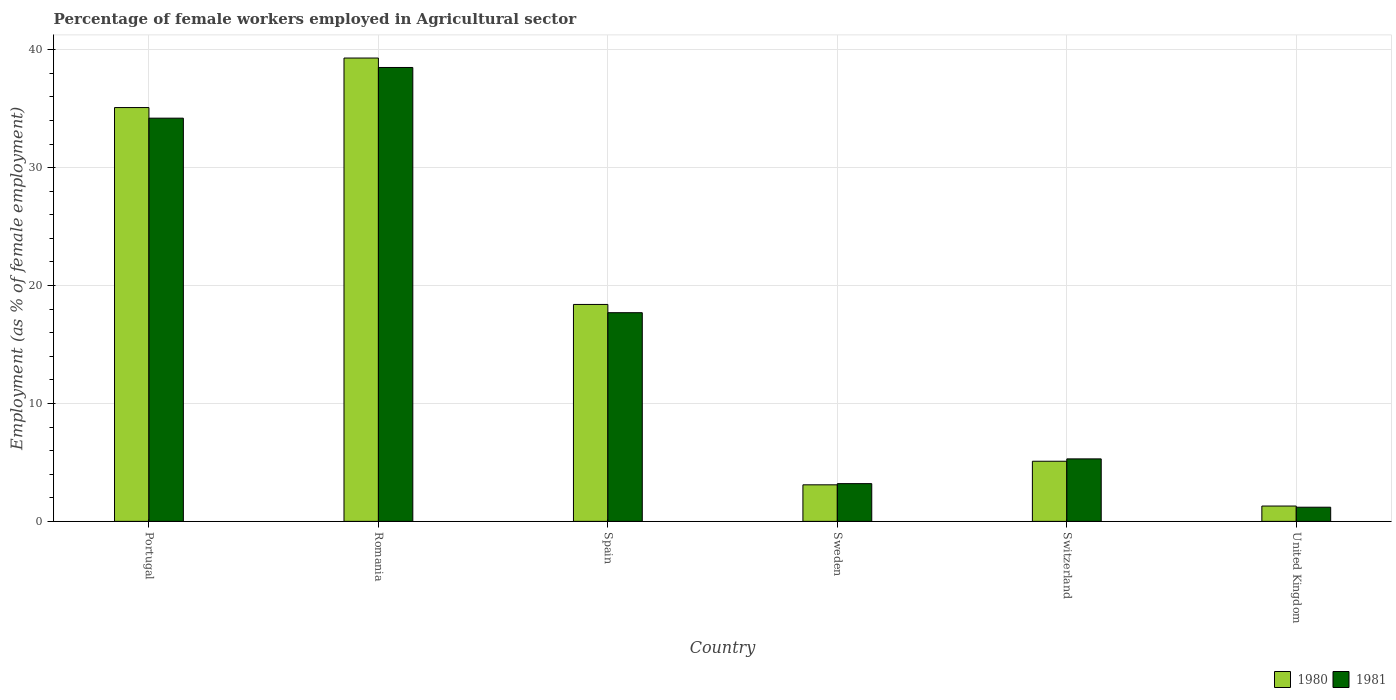How many groups of bars are there?
Provide a short and direct response. 6. How many bars are there on the 1st tick from the right?
Keep it short and to the point. 2. What is the label of the 3rd group of bars from the left?
Ensure brevity in your answer.  Spain. What is the percentage of females employed in Agricultural sector in 1980 in Portugal?
Your answer should be very brief. 35.1. Across all countries, what is the maximum percentage of females employed in Agricultural sector in 1980?
Keep it short and to the point. 39.3. Across all countries, what is the minimum percentage of females employed in Agricultural sector in 1981?
Your answer should be compact. 1.2. In which country was the percentage of females employed in Agricultural sector in 1980 maximum?
Your answer should be compact. Romania. In which country was the percentage of females employed in Agricultural sector in 1981 minimum?
Provide a succinct answer. United Kingdom. What is the total percentage of females employed in Agricultural sector in 1980 in the graph?
Offer a terse response. 102.3. What is the difference between the percentage of females employed in Agricultural sector in 1981 in Spain and that in Switzerland?
Provide a succinct answer. 12.4. What is the difference between the percentage of females employed in Agricultural sector in 1980 in Sweden and the percentage of females employed in Agricultural sector in 1981 in Switzerland?
Provide a succinct answer. -2.2. What is the average percentage of females employed in Agricultural sector in 1981 per country?
Provide a succinct answer. 16.68. What is the difference between the percentage of females employed in Agricultural sector of/in 1980 and percentage of females employed in Agricultural sector of/in 1981 in Portugal?
Your response must be concise. 0.9. What is the ratio of the percentage of females employed in Agricultural sector in 1981 in Spain to that in Switzerland?
Provide a succinct answer. 3.34. Is the percentage of females employed in Agricultural sector in 1980 in Sweden less than that in Switzerland?
Your answer should be very brief. Yes. What is the difference between the highest and the second highest percentage of females employed in Agricultural sector in 1981?
Keep it short and to the point. -16.5. What is the difference between the highest and the lowest percentage of females employed in Agricultural sector in 1980?
Your answer should be compact. 38. In how many countries, is the percentage of females employed in Agricultural sector in 1980 greater than the average percentage of females employed in Agricultural sector in 1980 taken over all countries?
Provide a short and direct response. 3. Is the sum of the percentage of females employed in Agricultural sector in 1980 in Spain and United Kingdom greater than the maximum percentage of females employed in Agricultural sector in 1981 across all countries?
Offer a very short reply. No. What does the 2nd bar from the right in Sweden represents?
Offer a very short reply. 1980. Are all the bars in the graph horizontal?
Make the answer very short. No. What is the difference between two consecutive major ticks on the Y-axis?
Provide a short and direct response. 10. Where does the legend appear in the graph?
Provide a short and direct response. Bottom right. How are the legend labels stacked?
Offer a very short reply. Horizontal. What is the title of the graph?
Provide a succinct answer. Percentage of female workers employed in Agricultural sector. What is the label or title of the X-axis?
Ensure brevity in your answer.  Country. What is the label or title of the Y-axis?
Provide a succinct answer. Employment (as % of female employment). What is the Employment (as % of female employment) in 1980 in Portugal?
Offer a terse response. 35.1. What is the Employment (as % of female employment) of 1981 in Portugal?
Ensure brevity in your answer.  34.2. What is the Employment (as % of female employment) of 1980 in Romania?
Make the answer very short. 39.3. What is the Employment (as % of female employment) of 1981 in Romania?
Provide a succinct answer. 38.5. What is the Employment (as % of female employment) of 1980 in Spain?
Provide a short and direct response. 18.4. What is the Employment (as % of female employment) in 1981 in Spain?
Your answer should be very brief. 17.7. What is the Employment (as % of female employment) in 1980 in Sweden?
Give a very brief answer. 3.1. What is the Employment (as % of female employment) of 1981 in Sweden?
Offer a terse response. 3.2. What is the Employment (as % of female employment) of 1980 in Switzerland?
Give a very brief answer. 5.1. What is the Employment (as % of female employment) of 1981 in Switzerland?
Give a very brief answer. 5.3. What is the Employment (as % of female employment) of 1980 in United Kingdom?
Your answer should be compact. 1.3. What is the Employment (as % of female employment) in 1981 in United Kingdom?
Provide a short and direct response. 1.2. Across all countries, what is the maximum Employment (as % of female employment) of 1980?
Give a very brief answer. 39.3. Across all countries, what is the maximum Employment (as % of female employment) in 1981?
Your response must be concise. 38.5. Across all countries, what is the minimum Employment (as % of female employment) of 1980?
Offer a terse response. 1.3. Across all countries, what is the minimum Employment (as % of female employment) of 1981?
Your answer should be very brief. 1.2. What is the total Employment (as % of female employment) of 1980 in the graph?
Provide a succinct answer. 102.3. What is the total Employment (as % of female employment) of 1981 in the graph?
Your response must be concise. 100.1. What is the difference between the Employment (as % of female employment) in 1981 in Portugal and that in Spain?
Your response must be concise. 16.5. What is the difference between the Employment (as % of female employment) of 1980 in Portugal and that in Switzerland?
Your answer should be compact. 30. What is the difference between the Employment (as % of female employment) of 1981 in Portugal and that in Switzerland?
Your answer should be compact. 28.9. What is the difference between the Employment (as % of female employment) of 1980 in Portugal and that in United Kingdom?
Make the answer very short. 33.8. What is the difference between the Employment (as % of female employment) in 1980 in Romania and that in Spain?
Provide a short and direct response. 20.9. What is the difference between the Employment (as % of female employment) in 1981 in Romania and that in Spain?
Make the answer very short. 20.8. What is the difference between the Employment (as % of female employment) of 1980 in Romania and that in Sweden?
Provide a short and direct response. 36.2. What is the difference between the Employment (as % of female employment) in 1981 in Romania and that in Sweden?
Provide a short and direct response. 35.3. What is the difference between the Employment (as % of female employment) in 1980 in Romania and that in Switzerland?
Your answer should be compact. 34.2. What is the difference between the Employment (as % of female employment) of 1981 in Romania and that in Switzerland?
Your answer should be compact. 33.2. What is the difference between the Employment (as % of female employment) in 1981 in Romania and that in United Kingdom?
Your response must be concise. 37.3. What is the difference between the Employment (as % of female employment) in 1980 in Spain and that in Sweden?
Your answer should be compact. 15.3. What is the difference between the Employment (as % of female employment) of 1981 in Spain and that in Switzerland?
Make the answer very short. 12.4. What is the difference between the Employment (as % of female employment) in 1981 in Spain and that in United Kingdom?
Ensure brevity in your answer.  16.5. What is the difference between the Employment (as % of female employment) in 1981 in Switzerland and that in United Kingdom?
Provide a succinct answer. 4.1. What is the difference between the Employment (as % of female employment) in 1980 in Portugal and the Employment (as % of female employment) in 1981 in Sweden?
Offer a very short reply. 31.9. What is the difference between the Employment (as % of female employment) of 1980 in Portugal and the Employment (as % of female employment) of 1981 in Switzerland?
Your response must be concise. 29.8. What is the difference between the Employment (as % of female employment) in 1980 in Portugal and the Employment (as % of female employment) in 1981 in United Kingdom?
Offer a very short reply. 33.9. What is the difference between the Employment (as % of female employment) in 1980 in Romania and the Employment (as % of female employment) in 1981 in Spain?
Your answer should be very brief. 21.6. What is the difference between the Employment (as % of female employment) in 1980 in Romania and the Employment (as % of female employment) in 1981 in Sweden?
Ensure brevity in your answer.  36.1. What is the difference between the Employment (as % of female employment) in 1980 in Romania and the Employment (as % of female employment) in 1981 in Switzerland?
Ensure brevity in your answer.  34. What is the difference between the Employment (as % of female employment) in 1980 in Romania and the Employment (as % of female employment) in 1981 in United Kingdom?
Offer a very short reply. 38.1. What is the difference between the Employment (as % of female employment) in 1980 in Spain and the Employment (as % of female employment) in 1981 in Switzerland?
Keep it short and to the point. 13.1. What is the difference between the Employment (as % of female employment) in 1980 in Spain and the Employment (as % of female employment) in 1981 in United Kingdom?
Keep it short and to the point. 17.2. What is the difference between the Employment (as % of female employment) of 1980 in Sweden and the Employment (as % of female employment) of 1981 in Switzerland?
Your answer should be compact. -2.2. What is the difference between the Employment (as % of female employment) in 1980 in Sweden and the Employment (as % of female employment) in 1981 in United Kingdom?
Offer a very short reply. 1.9. What is the average Employment (as % of female employment) of 1980 per country?
Provide a succinct answer. 17.05. What is the average Employment (as % of female employment) of 1981 per country?
Ensure brevity in your answer.  16.68. What is the difference between the Employment (as % of female employment) of 1980 and Employment (as % of female employment) of 1981 in Romania?
Keep it short and to the point. 0.8. What is the difference between the Employment (as % of female employment) in 1980 and Employment (as % of female employment) in 1981 in Spain?
Give a very brief answer. 0.7. What is the difference between the Employment (as % of female employment) in 1980 and Employment (as % of female employment) in 1981 in United Kingdom?
Keep it short and to the point. 0.1. What is the ratio of the Employment (as % of female employment) in 1980 in Portugal to that in Romania?
Your answer should be very brief. 0.89. What is the ratio of the Employment (as % of female employment) in 1981 in Portugal to that in Romania?
Keep it short and to the point. 0.89. What is the ratio of the Employment (as % of female employment) of 1980 in Portugal to that in Spain?
Provide a short and direct response. 1.91. What is the ratio of the Employment (as % of female employment) in 1981 in Portugal to that in Spain?
Give a very brief answer. 1.93. What is the ratio of the Employment (as % of female employment) in 1980 in Portugal to that in Sweden?
Your answer should be compact. 11.32. What is the ratio of the Employment (as % of female employment) in 1981 in Portugal to that in Sweden?
Ensure brevity in your answer.  10.69. What is the ratio of the Employment (as % of female employment) of 1980 in Portugal to that in Switzerland?
Give a very brief answer. 6.88. What is the ratio of the Employment (as % of female employment) of 1981 in Portugal to that in Switzerland?
Give a very brief answer. 6.45. What is the ratio of the Employment (as % of female employment) of 1980 in Portugal to that in United Kingdom?
Provide a succinct answer. 27. What is the ratio of the Employment (as % of female employment) of 1981 in Portugal to that in United Kingdom?
Your answer should be very brief. 28.5. What is the ratio of the Employment (as % of female employment) in 1980 in Romania to that in Spain?
Your answer should be very brief. 2.14. What is the ratio of the Employment (as % of female employment) in 1981 in Romania to that in Spain?
Offer a very short reply. 2.18. What is the ratio of the Employment (as % of female employment) of 1980 in Romania to that in Sweden?
Your answer should be compact. 12.68. What is the ratio of the Employment (as % of female employment) of 1981 in Romania to that in Sweden?
Provide a succinct answer. 12.03. What is the ratio of the Employment (as % of female employment) in 1980 in Romania to that in Switzerland?
Your answer should be compact. 7.71. What is the ratio of the Employment (as % of female employment) in 1981 in Romania to that in Switzerland?
Provide a succinct answer. 7.26. What is the ratio of the Employment (as % of female employment) of 1980 in Romania to that in United Kingdom?
Your answer should be very brief. 30.23. What is the ratio of the Employment (as % of female employment) of 1981 in Romania to that in United Kingdom?
Offer a terse response. 32.08. What is the ratio of the Employment (as % of female employment) in 1980 in Spain to that in Sweden?
Offer a very short reply. 5.94. What is the ratio of the Employment (as % of female employment) of 1981 in Spain to that in Sweden?
Your answer should be compact. 5.53. What is the ratio of the Employment (as % of female employment) of 1980 in Spain to that in Switzerland?
Provide a short and direct response. 3.61. What is the ratio of the Employment (as % of female employment) in 1981 in Spain to that in Switzerland?
Ensure brevity in your answer.  3.34. What is the ratio of the Employment (as % of female employment) in 1980 in Spain to that in United Kingdom?
Your response must be concise. 14.15. What is the ratio of the Employment (as % of female employment) of 1981 in Spain to that in United Kingdom?
Offer a very short reply. 14.75. What is the ratio of the Employment (as % of female employment) of 1980 in Sweden to that in Switzerland?
Give a very brief answer. 0.61. What is the ratio of the Employment (as % of female employment) of 1981 in Sweden to that in Switzerland?
Your response must be concise. 0.6. What is the ratio of the Employment (as % of female employment) of 1980 in Sweden to that in United Kingdom?
Offer a very short reply. 2.38. What is the ratio of the Employment (as % of female employment) in 1981 in Sweden to that in United Kingdom?
Your answer should be compact. 2.67. What is the ratio of the Employment (as % of female employment) in 1980 in Switzerland to that in United Kingdom?
Make the answer very short. 3.92. What is the ratio of the Employment (as % of female employment) of 1981 in Switzerland to that in United Kingdom?
Your answer should be very brief. 4.42. What is the difference between the highest and the second highest Employment (as % of female employment) in 1980?
Provide a short and direct response. 4.2. What is the difference between the highest and the lowest Employment (as % of female employment) of 1980?
Give a very brief answer. 38. What is the difference between the highest and the lowest Employment (as % of female employment) of 1981?
Provide a succinct answer. 37.3. 